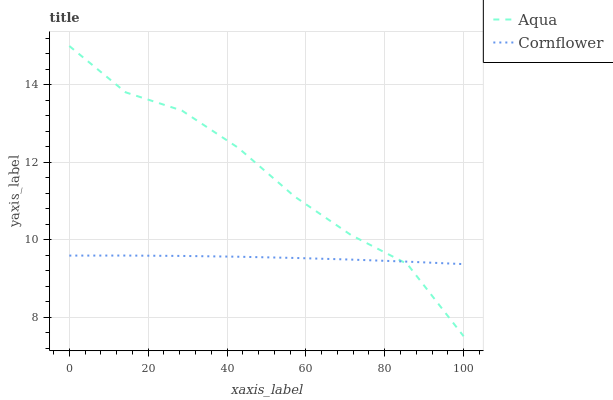Does Cornflower have the minimum area under the curve?
Answer yes or no. Yes. Does Aqua have the maximum area under the curve?
Answer yes or no. Yes. Does Aqua have the minimum area under the curve?
Answer yes or no. No. Is Cornflower the smoothest?
Answer yes or no. Yes. Is Aqua the roughest?
Answer yes or no. Yes. Is Aqua the smoothest?
Answer yes or no. No. Does Aqua have the lowest value?
Answer yes or no. Yes. Does Aqua have the highest value?
Answer yes or no. Yes. Does Aqua intersect Cornflower?
Answer yes or no. Yes. Is Aqua less than Cornflower?
Answer yes or no. No. Is Aqua greater than Cornflower?
Answer yes or no. No. 